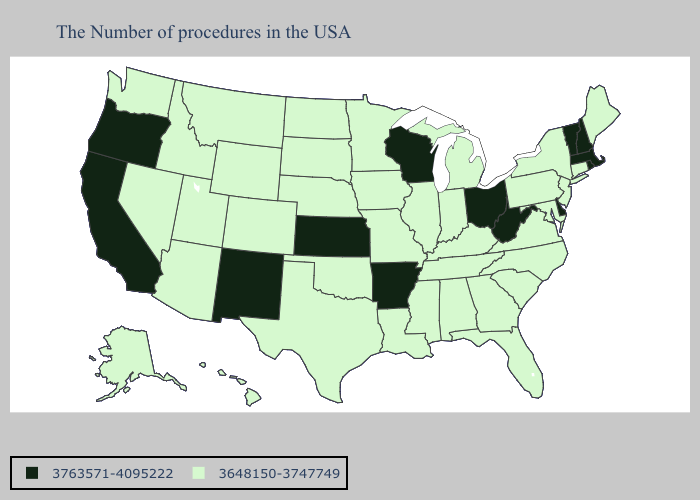Does Michigan have a lower value than West Virginia?
Write a very short answer. Yes. What is the lowest value in the USA?
Give a very brief answer. 3648150-3747749. Among the states that border Utah , does Arizona have the highest value?
Write a very short answer. No. Name the states that have a value in the range 3763571-4095222?
Keep it brief. Massachusetts, Rhode Island, New Hampshire, Vermont, Delaware, West Virginia, Ohio, Wisconsin, Arkansas, Kansas, New Mexico, California, Oregon. Is the legend a continuous bar?
Write a very short answer. No. What is the highest value in the MidWest ?
Give a very brief answer. 3763571-4095222. What is the value of Kansas?
Answer briefly. 3763571-4095222. Which states have the lowest value in the South?
Keep it brief. Maryland, Virginia, North Carolina, South Carolina, Florida, Georgia, Kentucky, Alabama, Tennessee, Mississippi, Louisiana, Oklahoma, Texas. What is the value of Wyoming?
Concise answer only. 3648150-3747749. Does New York have a higher value than Tennessee?
Short answer required. No. Name the states that have a value in the range 3648150-3747749?
Short answer required. Maine, Connecticut, New York, New Jersey, Maryland, Pennsylvania, Virginia, North Carolina, South Carolina, Florida, Georgia, Michigan, Kentucky, Indiana, Alabama, Tennessee, Illinois, Mississippi, Louisiana, Missouri, Minnesota, Iowa, Nebraska, Oklahoma, Texas, South Dakota, North Dakota, Wyoming, Colorado, Utah, Montana, Arizona, Idaho, Nevada, Washington, Alaska, Hawaii. Name the states that have a value in the range 3648150-3747749?
Answer briefly. Maine, Connecticut, New York, New Jersey, Maryland, Pennsylvania, Virginia, North Carolina, South Carolina, Florida, Georgia, Michigan, Kentucky, Indiana, Alabama, Tennessee, Illinois, Mississippi, Louisiana, Missouri, Minnesota, Iowa, Nebraska, Oklahoma, Texas, South Dakota, North Dakota, Wyoming, Colorado, Utah, Montana, Arizona, Idaho, Nevada, Washington, Alaska, Hawaii. Among the states that border California , does Oregon have the lowest value?
Be succinct. No. Name the states that have a value in the range 3763571-4095222?
Be succinct. Massachusetts, Rhode Island, New Hampshire, Vermont, Delaware, West Virginia, Ohio, Wisconsin, Arkansas, Kansas, New Mexico, California, Oregon. 